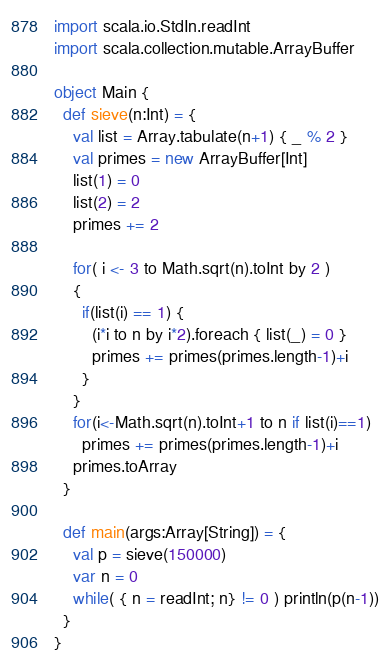Convert code to text. <code><loc_0><loc_0><loc_500><loc_500><_Scala_>import scala.io.StdIn.readInt
import scala.collection.mutable.ArrayBuffer

object Main {
  def sieve(n:Int) = {
    val list = Array.tabulate(n+1) { _ % 2 }
    val primes = new ArrayBuffer[Int]
    list(1) = 0
    list(2) = 2
    primes += 2

    for( i <- 3 to Math.sqrt(n).toInt by 2 )
    {
      if(list(i) == 1) {
        (i*i to n by i*2).foreach { list(_) = 0 }
        primes += primes(primes.length-1)+i
      }
    }
    for(i<-Math.sqrt(n).toInt+1 to n if list(i)==1)
      primes += primes(primes.length-1)+i
    primes.toArray
  }

  def main(args:Array[String]) = {
    val p = sieve(150000)
    var n = 0
    while( { n = readInt; n} != 0 ) println(p(n-1))
  }
}</code> 